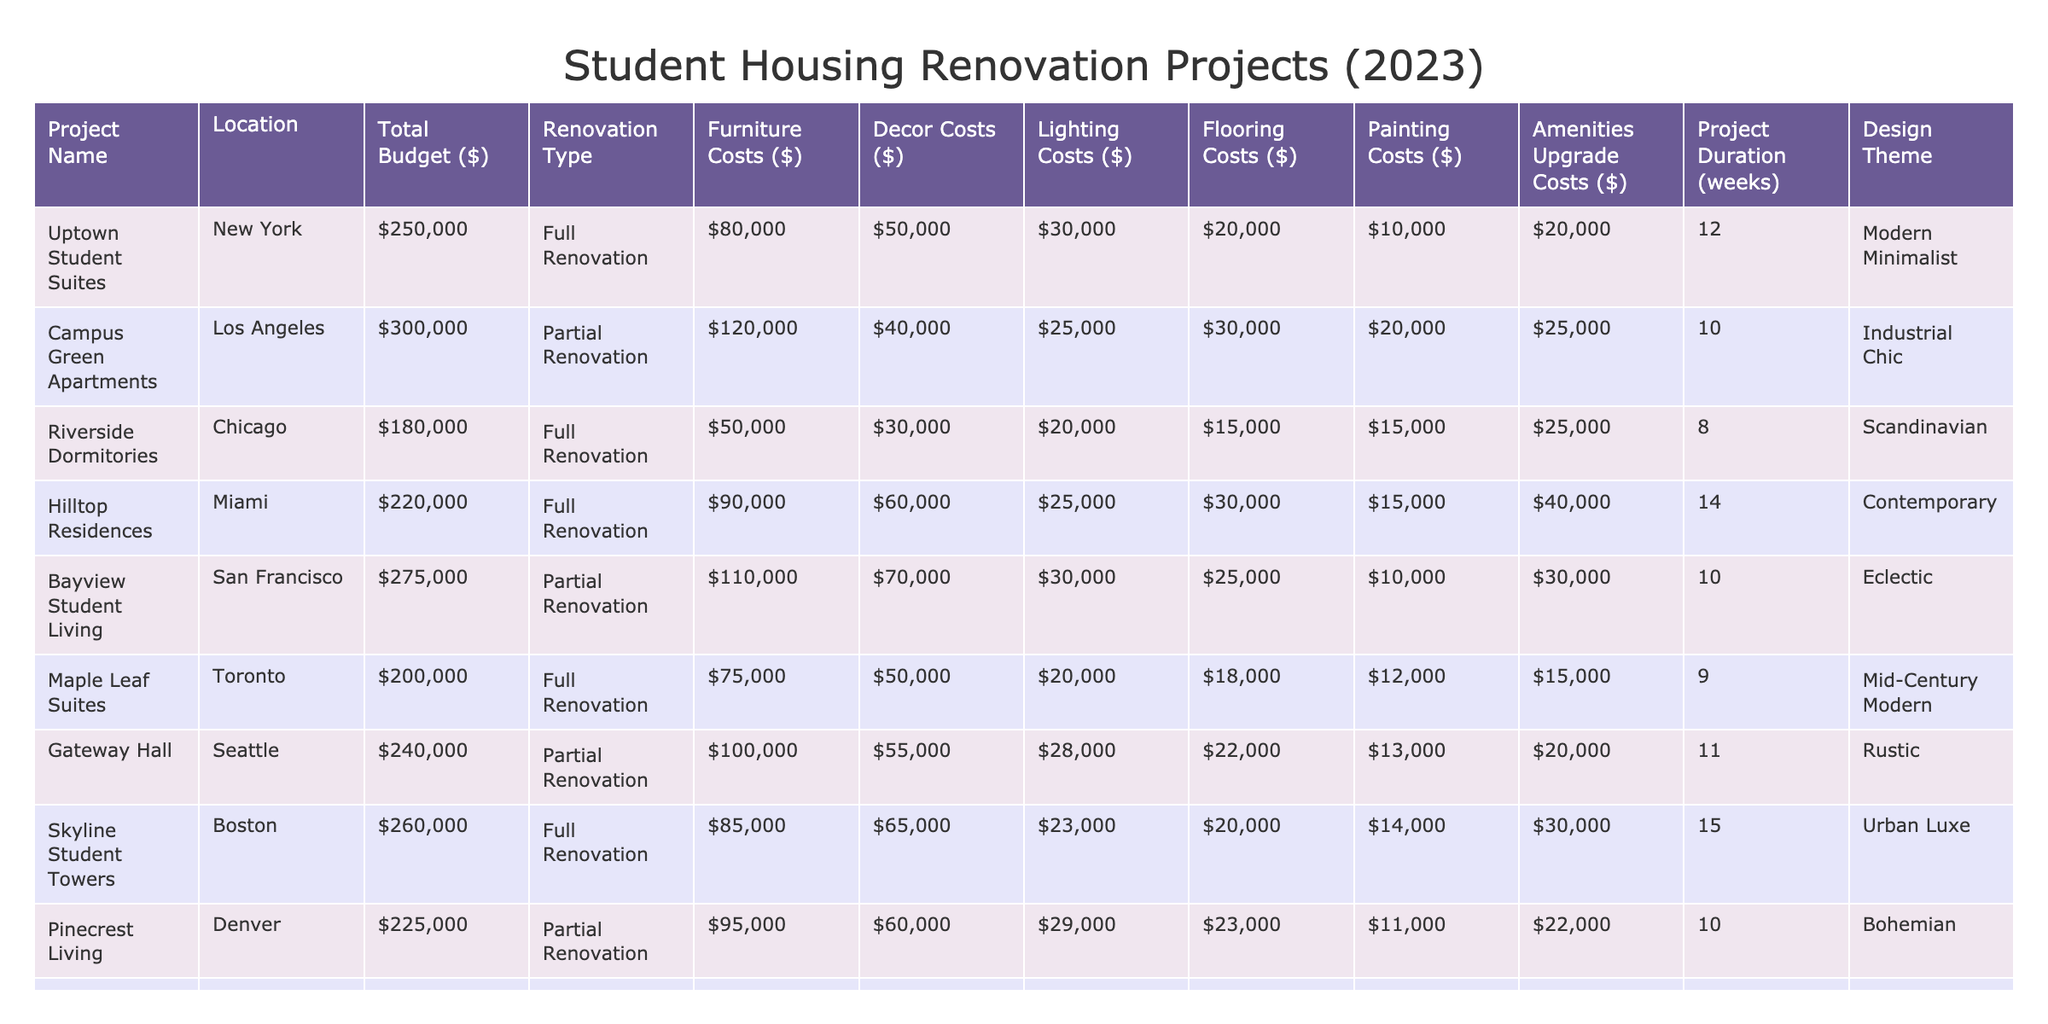What is the total budget for the Riverside Dormitories project? In the table, I will look for the row corresponding to Riverside Dormitories. The Total Budget ($) listed there is 180000.
Answer: 180000 Which project has the highest furniture costs? I will review the Furniture Costs ($) column to find the maximum value. The highest value is 120000 for Campus Green Apartments.
Answer: Campus Green Apartments What is the average project duration for full renovations? I will find all projects classified as Full Renovation, which are 5 in total. Their durations are 12, 8, 14, 15, and 9 weeks. Adding these gives a total of 58 weeks, and dividing by 5 gives an average of 11.6 weeks.
Answer: 11.6 weeks Is the total budget for Hilltop Residences greater than the total budget for Bayview Student Living? I will compare the Total Budgets: Hilltop Residences has 220000, and Bayview Student Living has 275000. Since 220000 is less than 275000, the statement is false.
Answer: No What is the total cost of decor for all projects in Chicago? I will look at the project in Chicago, Riverside Dormitories, and note the Decor Costs ($) is 30000. This is the total as it's the only project there.
Answer: 30000 Which design theme is associated with the highest overall cost, including all expense categories? I will sum all the costs for each project based on their themes. The total costs are: Modern Minimalist (250000), Industrial Chic (300000), Scandinavian (180000), Contemporary (220000), Eclectic (275000), Mid-Century Modern (200000), Rustic (240000), Urban Luxe (260000), Bohemian (225000), and Transitional (190000). The highest total is for Industrial Chic at 300000.
Answer: Industrial Chic How much more do painting costs total for the Uptown Student Suites compared to the Nest Apartments? For Uptown Student Suites, the Painting Costs ($) is 10000, and for The Nest Apartments, it is 13000. The difference is 13000 - 10000 = 3000.
Answer: 3000 What is the smallest total budget among all projects? I will look through the Total Budget ($) column and find that the smallest total is 180000 for Riverside Dormitories.
Answer: 180000 Do any of the projects in Denver have amenities upgrade costs greater than 20000? Checking Pinecrest Living in Denver, the Amenities Upgrade Costs ($) is 22000, which is greater than 20000, making the statement true.
Answer: Yes What percentage of the total budget for the Skyline Student Towers is allocated for furniture costs? The Total Budget ($) for Skyline Student Towers is 260000 and Furniture Costs ($) is 85000. To find the percentage, I calculate (85000 / 260000) * 100 = 32.69%.
Answer: 32.69% 